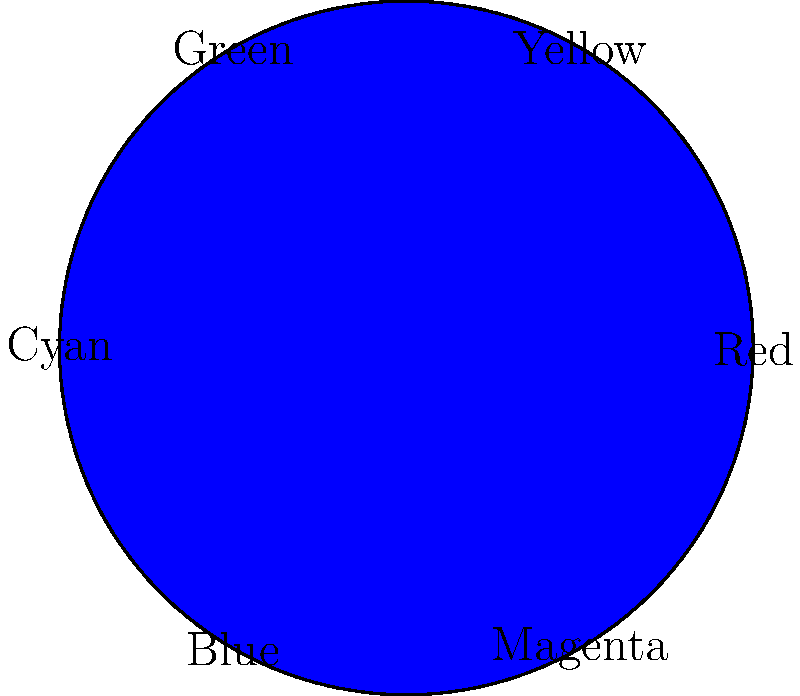In the color wheel shown above, which color would result from mixing equal parts of Red and Green? To answer this question, we need to understand the basics of color theory and additive color mixing:

1. The color wheel shows the primary colors (Red, Green, Blue) and their combinations.
2. In additive color mixing, combining two primary colors creates a secondary color.
3. Red and Green are adjacent primary colors on the wheel.
4. When mixing equal parts of two adjacent primary colors, we get the secondary color between them.
5. Looking at the color wheel, we can see that Yellow is positioned between Red and Green.

Therefore, mixing equal parts of Red and Green would result in Yellow.
Answer: Yellow 